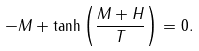<formula> <loc_0><loc_0><loc_500><loc_500>- M + \tanh \left ( \frac { M + H } T \right ) = 0 .</formula> 